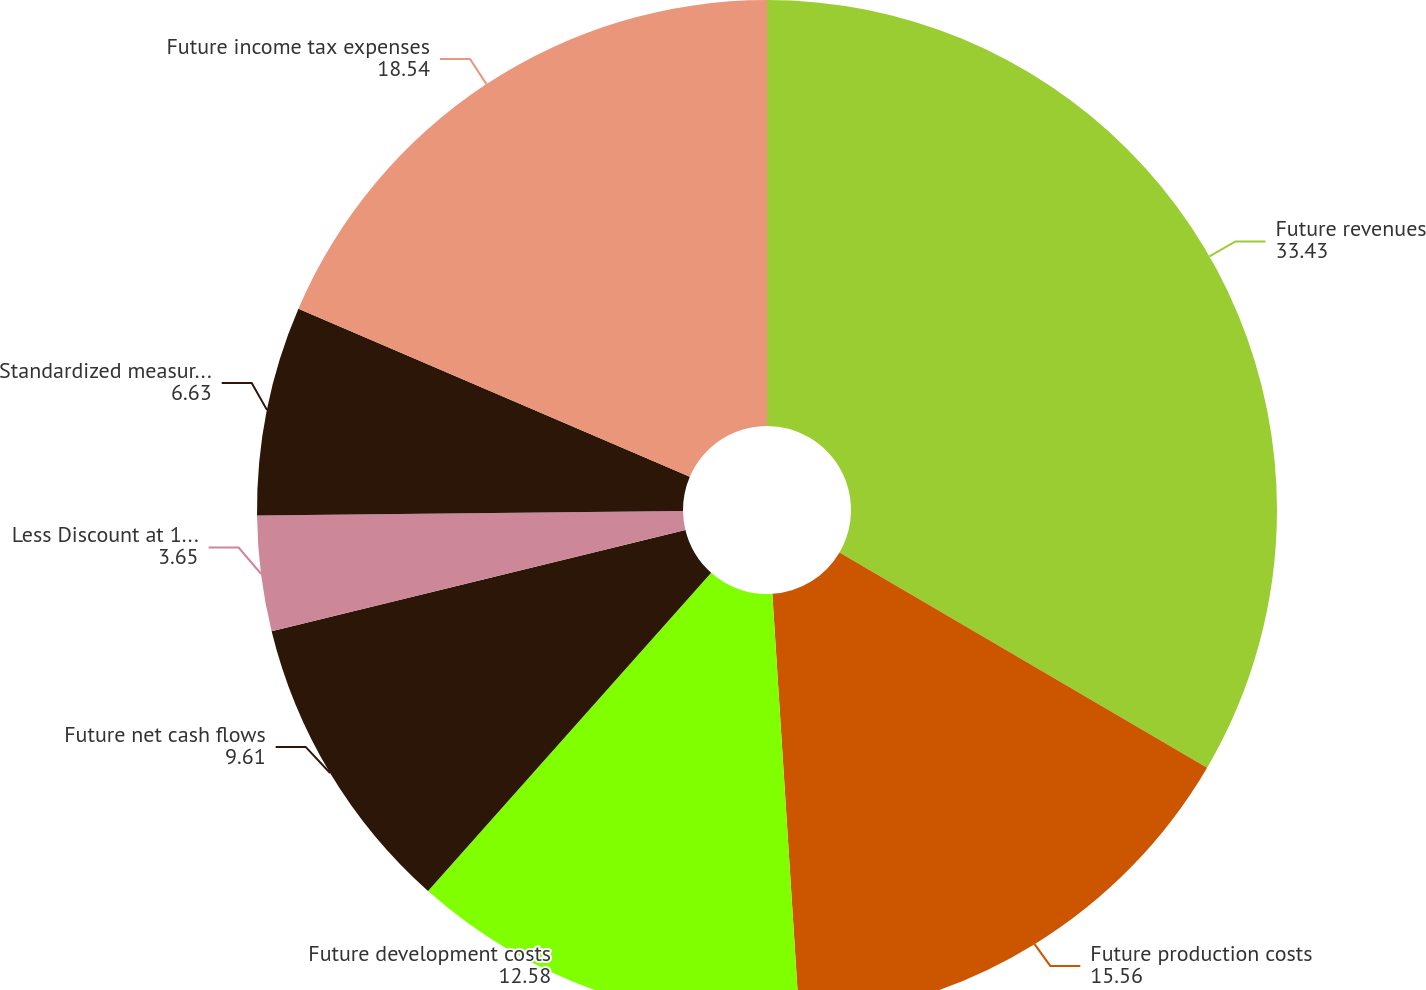<chart> <loc_0><loc_0><loc_500><loc_500><pie_chart><fcel>Future revenues<fcel>Future production costs<fcel>Future development costs<fcel>Future net cash flows<fcel>Less Discount at 10 annual<fcel>Standardized measure of<fcel>Future income tax expenses<nl><fcel>33.43%<fcel>15.56%<fcel>12.58%<fcel>9.61%<fcel>3.65%<fcel>6.63%<fcel>18.54%<nl></chart> 